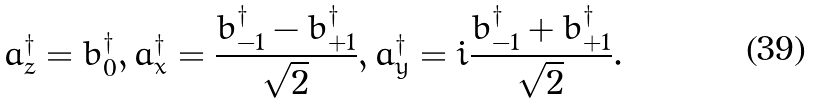<formula> <loc_0><loc_0><loc_500><loc_500>a _ { z } ^ { \dagger } = b _ { 0 } ^ { \dagger } , a _ { x } ^ { \dagger } = \frac { b _ { - 1 } ^ { \dagger } - b _ { + 1 } ^ { \dagger } } { \sqrt { 2 } } , a _ { y } ^ { \dagger } = i \frac { b _ { - 1 } ^ { \dagger } + b _ { + 1 } ^ { \dagger } } { \sqrt { 2 } } .</formula> 